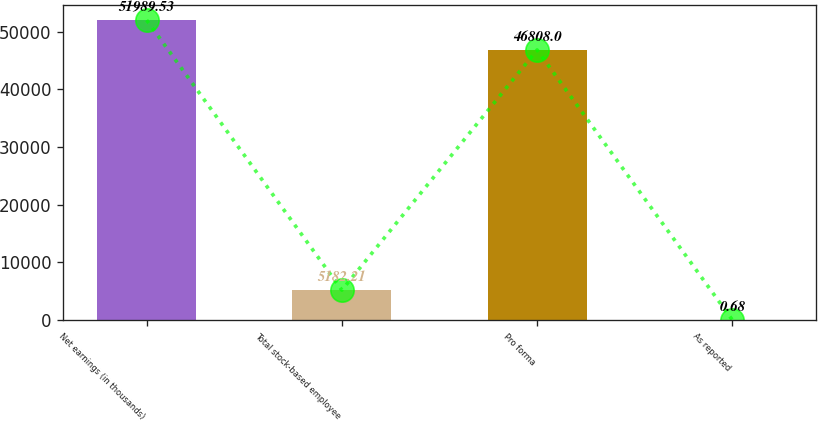Convert chart. <chart><loc_0><loc_0><loc_500><loc_500><bar_chart><fcel>Net earnings (in thousands)<fcel>Total stock-based employee<fcel>Pro forma<fcel>As reported<nl><fcel>51989.5<fcel>5182.21<fcel>46808<fcel>0.68<nl></chart> 